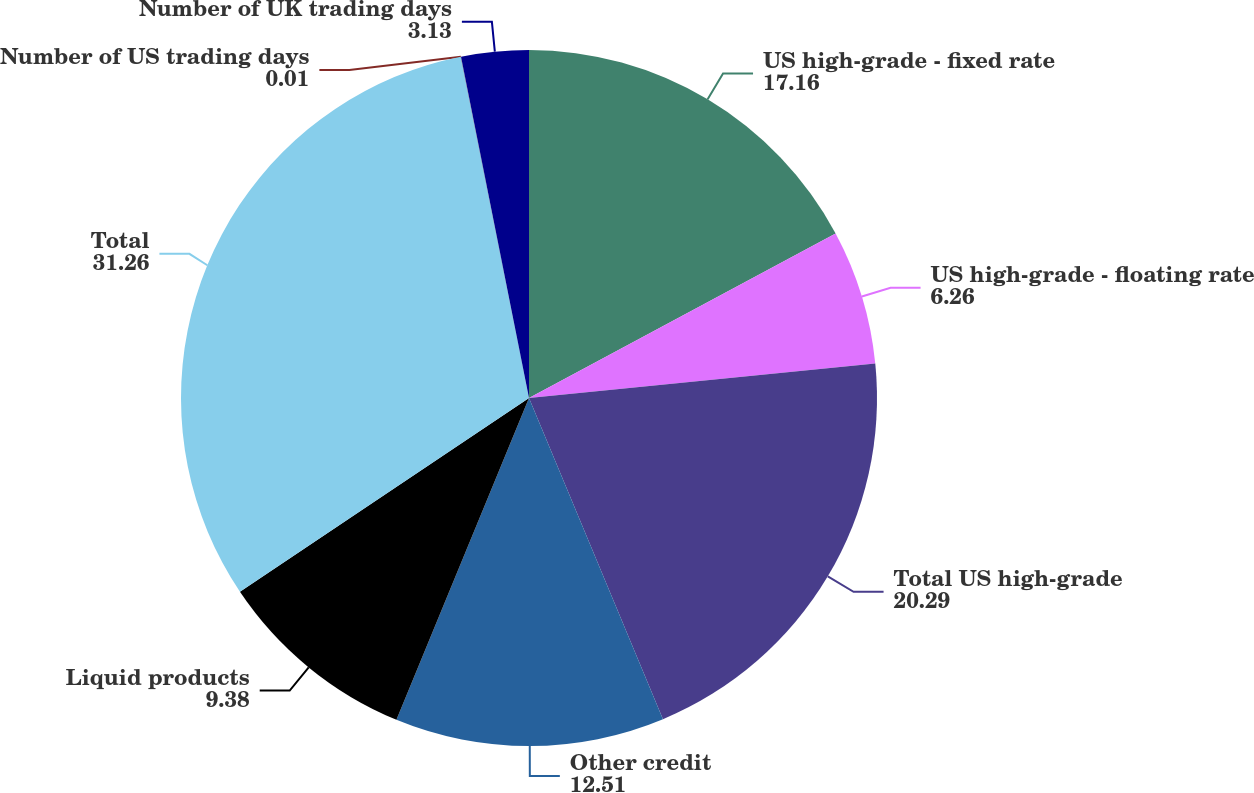<chart> <loc_0><loc_0><loc_500><loc_500><pie_chart><fcel>US high-grade - fixed rate<fcel>US high-grade - floating rate<fcel>Total US high-grade<fcel>Other credit<fcel>Liquid products<fcel>Total<fcel>Number of US trading days<fcel>Number of UK trading days<nl><fcel>17.16%<fcel>6.26%<fcel>20.29%<fcel>12.51%<fcel>9.38%<fcel>31.26%<fcel>0.01%<fcel>3.13%<nl></chart> 